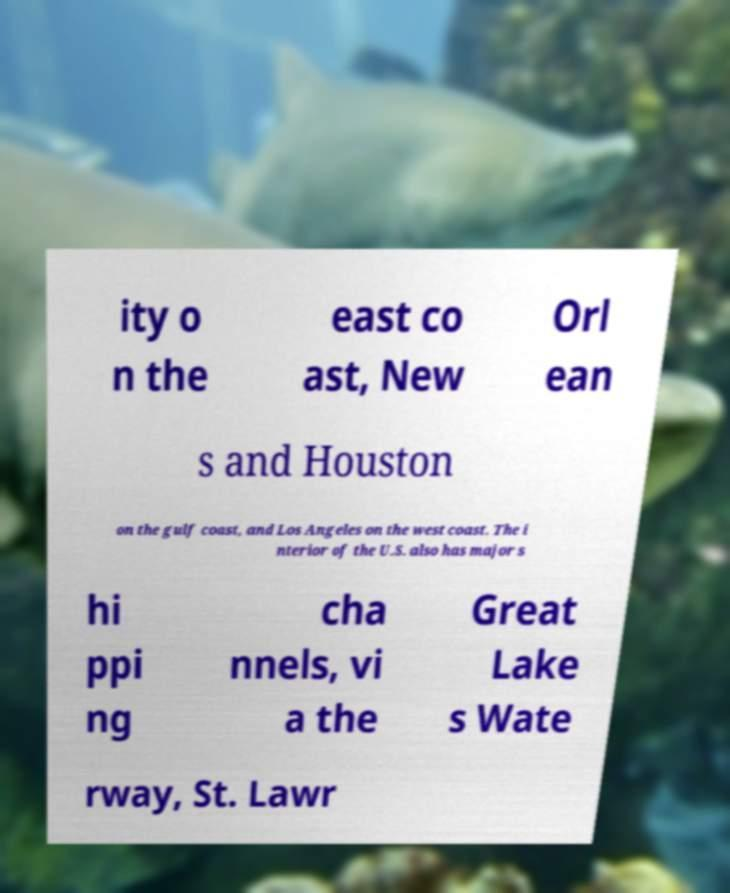Could you extract and type out the text from this image? ity o n the east co ast, New Orl ean s and Houston on the gulf coast, and Los Angeles on the west coast. The i nterior of the U.S. also has major s hi ppi ng cha nnels, vi a the Great Lake s Wate rway, St. Lawr 